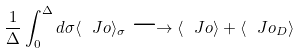Convert formula to latex. <formula><loc_0><loc_0><loc_500><loc_500>\frac { 1 } { \Delta } \int _ { 0 } ^ { \Delta } d \sigma \langle \ J o \rangle _ { \sigma } \longrightarrow \langle \ J o \rangle + \langle \ J o _ { D } \rangle</formula> 